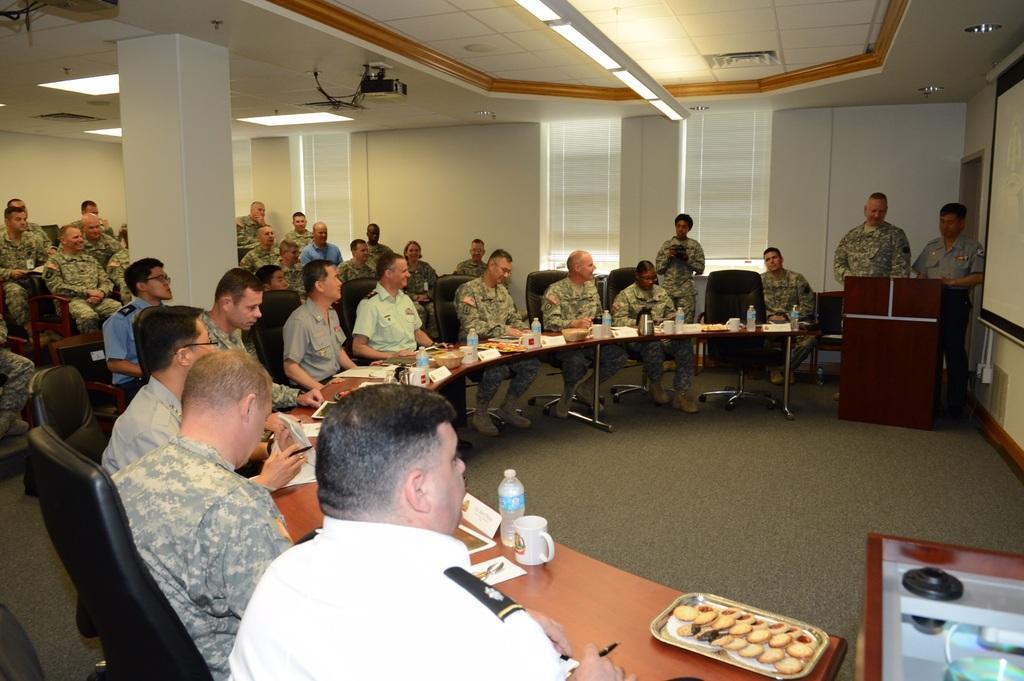How would you summarize this image in a sentence or two? In this image I can see people where few of them standing and rest all are sitting on chairs. I can also see all of them are wearing uniforms. Here on this table I can see number of water bottles, cups, biscuits and few papers. I can also see a projector machine and its screen. 